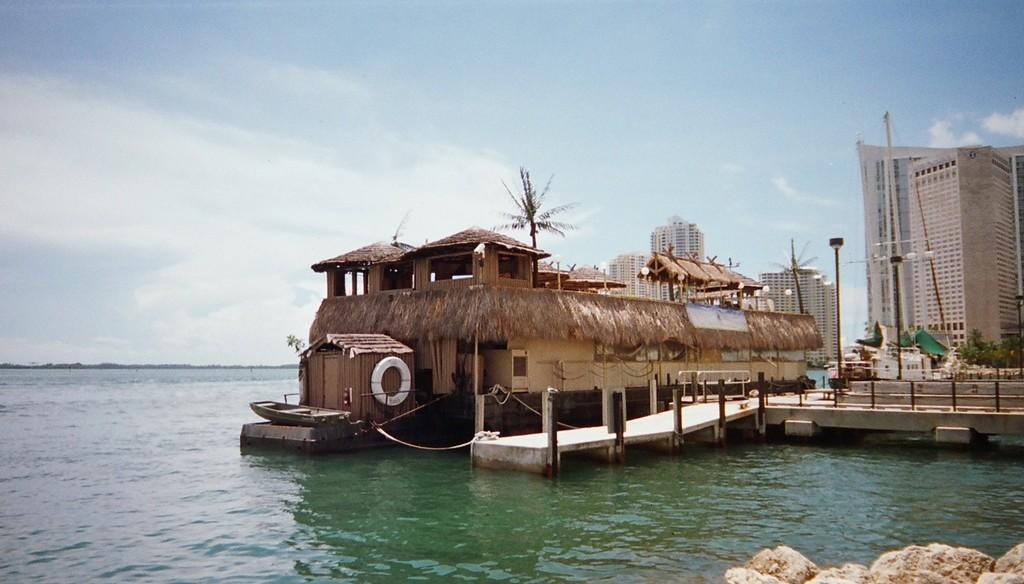What type of boat is in the image? There is a house boat in the image. What can be seen near the house boat? There are poles and trees visible in the image. What is the surrounding environment like? There is water visible in the image, and there are buildings and trees present. What can be seen in the background of the image? The sky is visible in the background of the image. How many hands are visible in the image? There are no hands visible in the image. What level of experience does the beginner have in the image? There is no indication of any person's experience level in the image. 